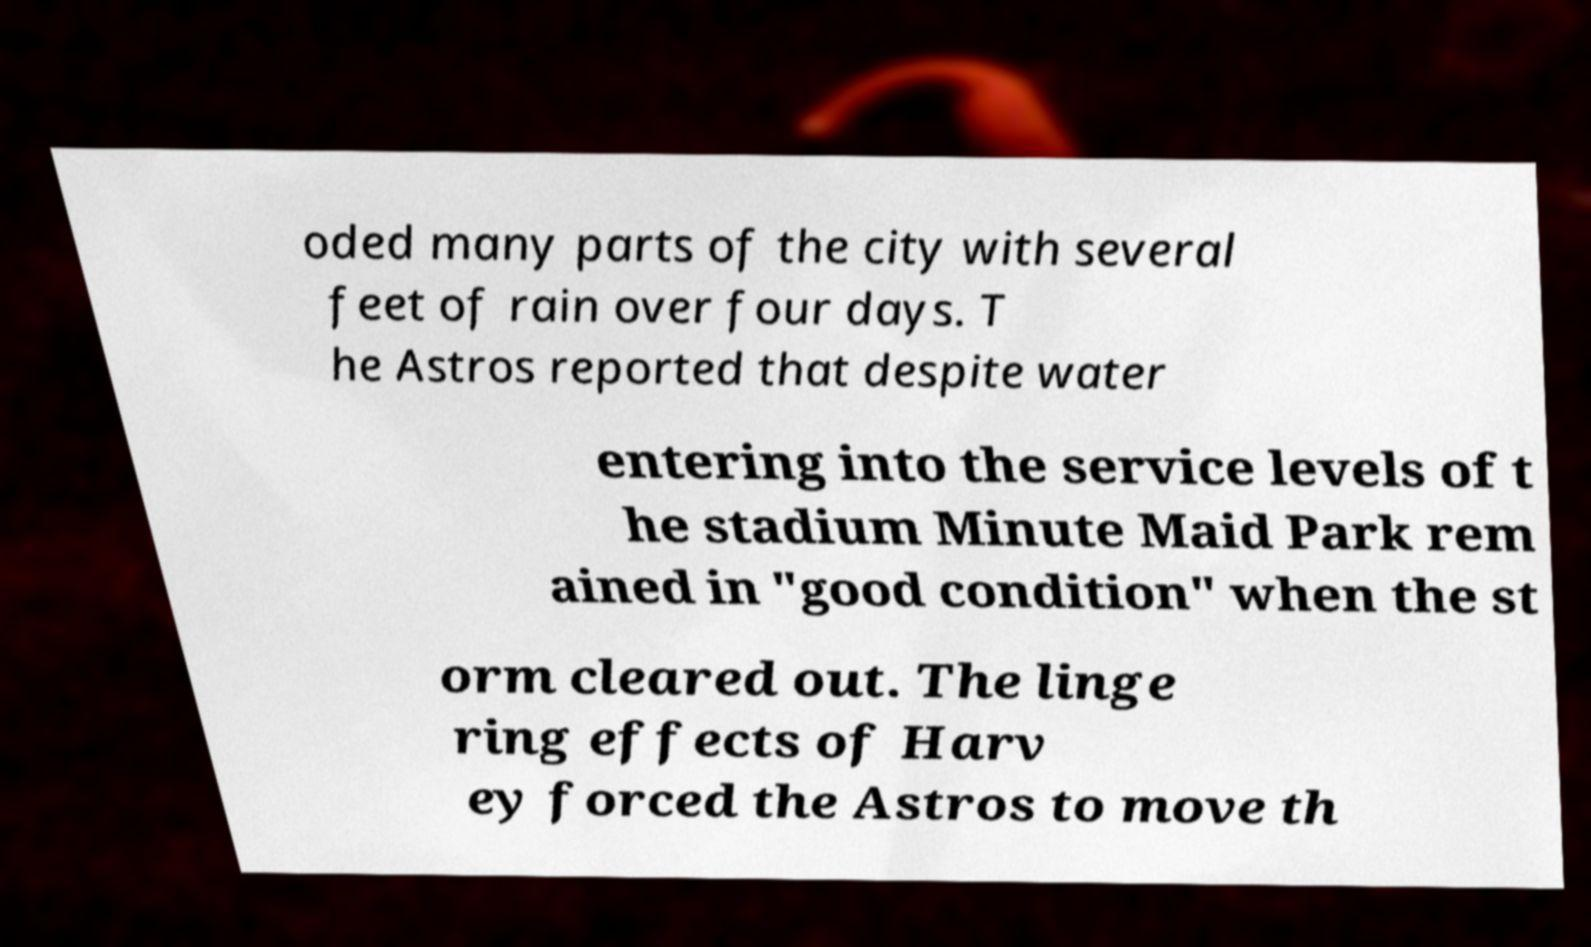What messages or text are displayed in this image? I need them in a readable, typed format. oded many parts of the city with several feet of rain over four days. T he Astros reported that despite water entering into the service levels of t he stadium Minute Maid Park rem ained in "good condition" when the st orm cleared out. The linge ring effects of Harv ey forced the Astros to move th 